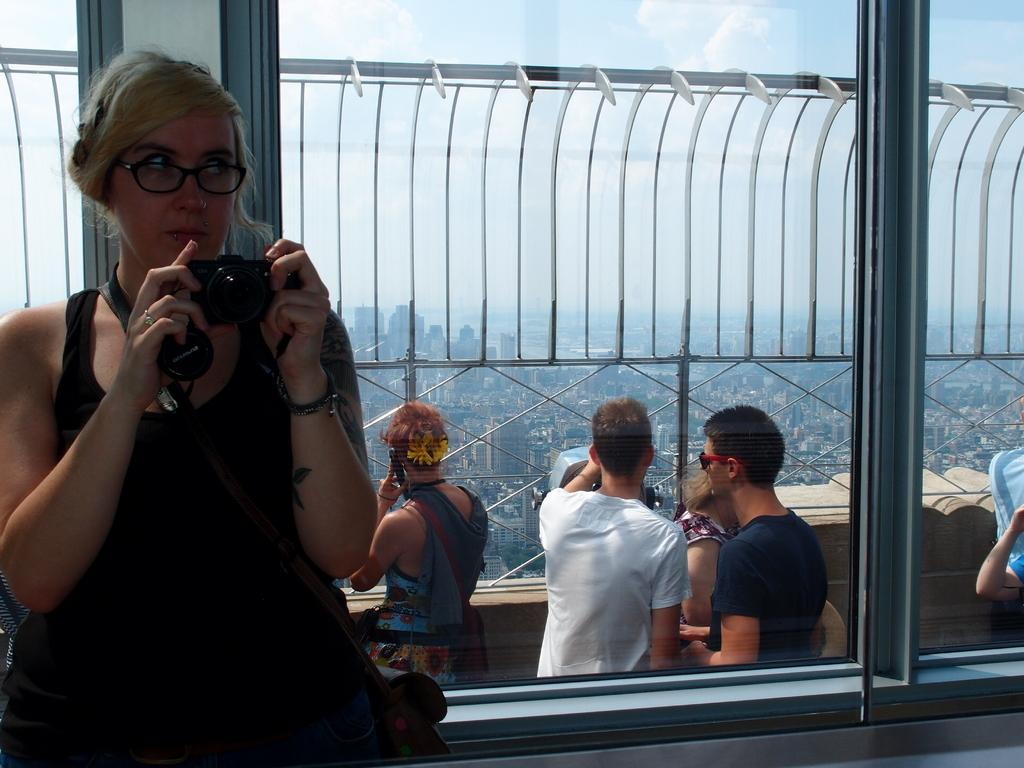What is the woman on the left side of the image doing? The woman is standing on the left side of the image and holding a camera. What can be seen in the background of the image? In the background of the image, there are clouds in the sky, buildings, a wall, and people. What might the woman be planning to do with the camera? The woman might be planning to take a picture or capture a moment with the camera. What type of hole can be seen in the woman's hair in the image? There is no hole visible in the woman's hair in the image. 